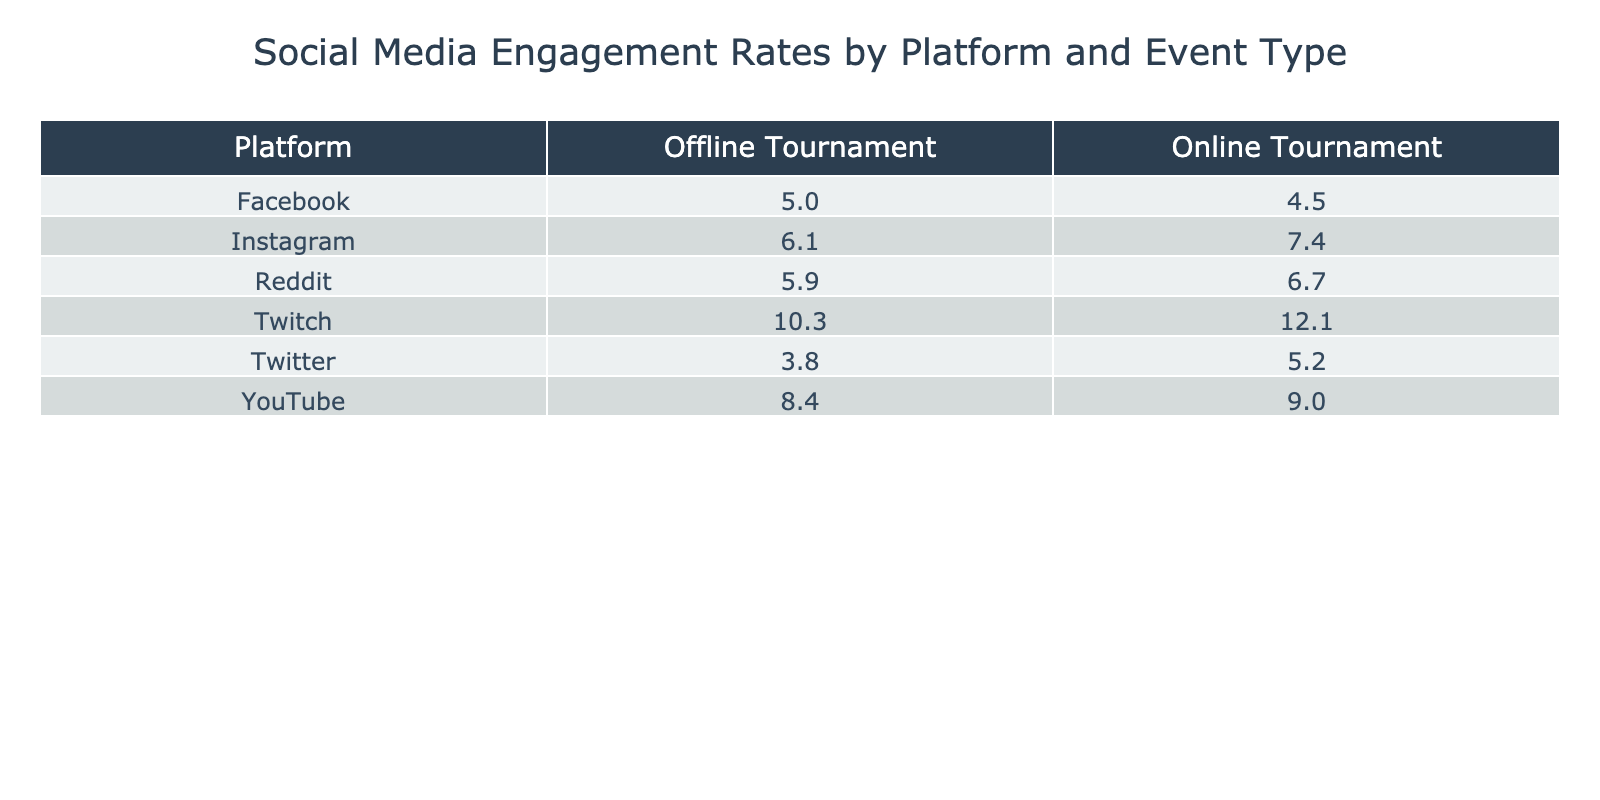What is the engagement rate for Instagram during online tournaments? The engagement rate for Instagram is listed under the "Online Tournament" column. Referring to the corresponding row, the engagement rate is 7.4%.
Answer: 7.4% Which platform has the highest engagement rate for offline tournaments? By inspecting the "Offline Tournament" column, Twitch has the highest engagement rate of 10.3%.
Answer: 10.3% What is the difference in engagement rates between Twitter for online and offline tournaments? The engagement rate for Twitter during online tournaments is 5.2% and for offline tournaments is 3.8%. The difference is calculated as 5.2% - 3.8% = 1.4%.
Answer: 1.4% True or False: YouTube has a higher engagement rate for offline tournaments than Instagram. Checking the engagement rates, YouTube's offline rate is 8.4% while Instagram’s offline rate is 6.1%. Since 8.4% is greater than 6.1%, the statement is true.
Answer: True What is the average engagement rate for all platforms during online tournaments? The engagement rates for online tournaments across all platforms are: 5.2% (Twitter), 7.4% (Instagram), 4.5% (Facebook), 9.0% (YouTube), 12.1% (Twitch), and 6.7% (Reddit). Summing these gives 5.2 + 7.4 + 4.5 + 9.0 + 12.1 + 6.7 = 45.0%. There are 6 platforms, so the average is 45.0 / 6 = 7.5%.
Answer: 7.5% What is the engagement rate for Facebook during offline tournaments? The engagement rate for Facebook is specifically provided under the "Offline Tournament" column. The rate is 5.0%.
Answer: 5.0% 